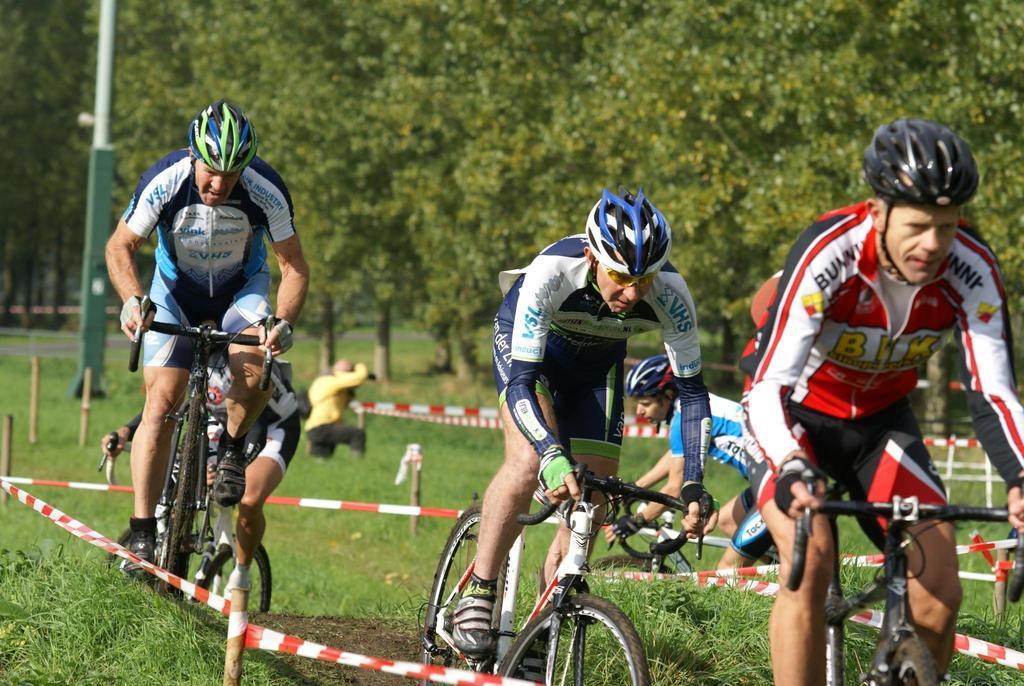Could you give a brief overview of what you see in this image? In this image there are a few people riding a bicycle on the path. On the either side of the path there is a fence, there is a person holding an object and standing on the surface of the grass, there is a pole. In the background there are trees. 